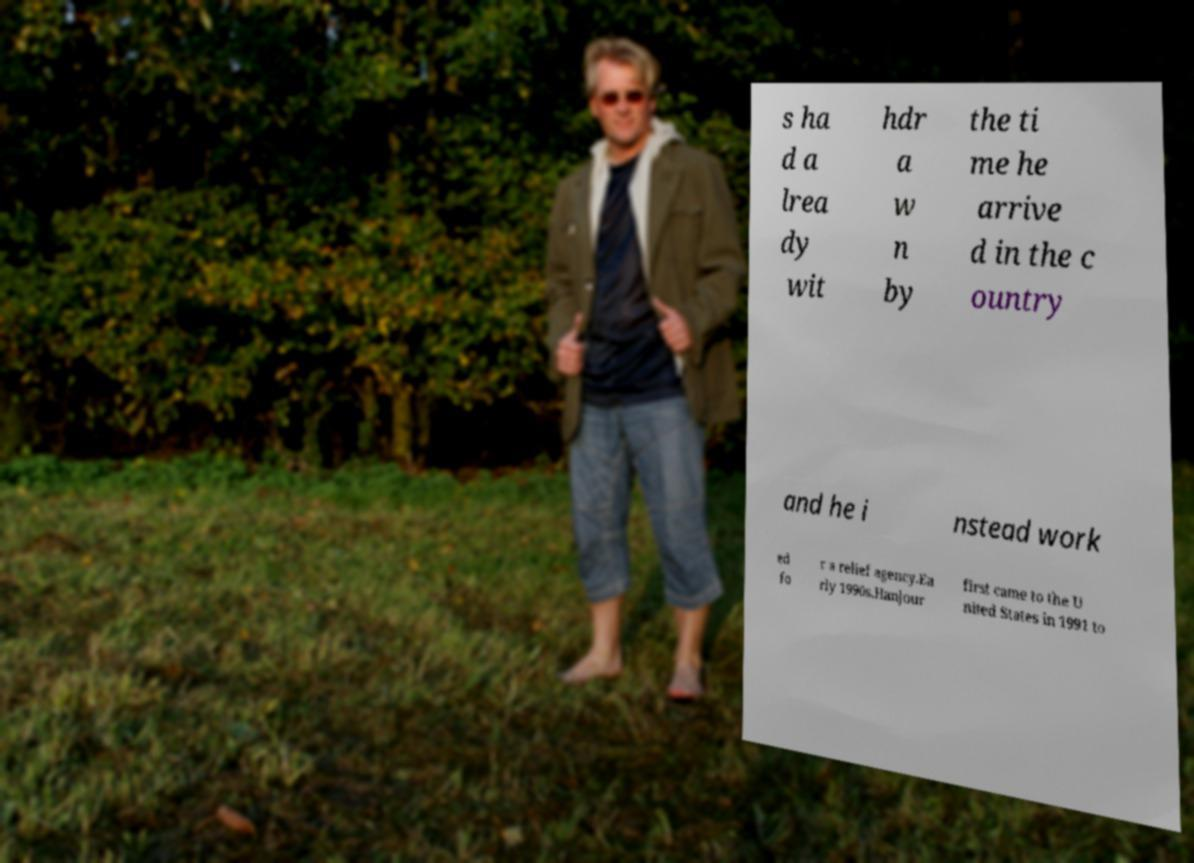Please identify and transcribe the text found in this image. s ha d a lrea dy wit hdr a w n by the ti me he arrive d in the c ountry and he i nstead work ed fo r a relief agency.Ea rly 1990s.Hanjour first came to the U nited States in 1991 to 